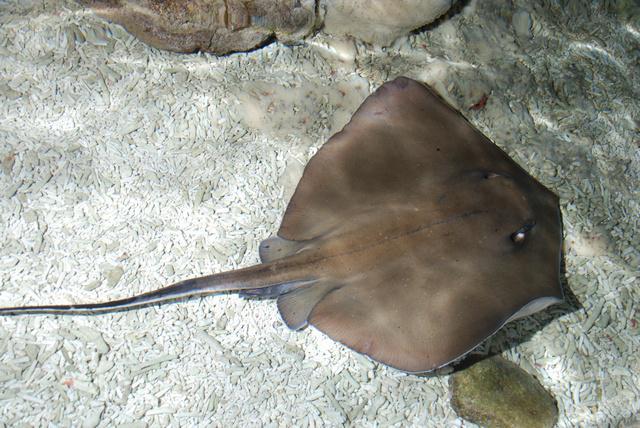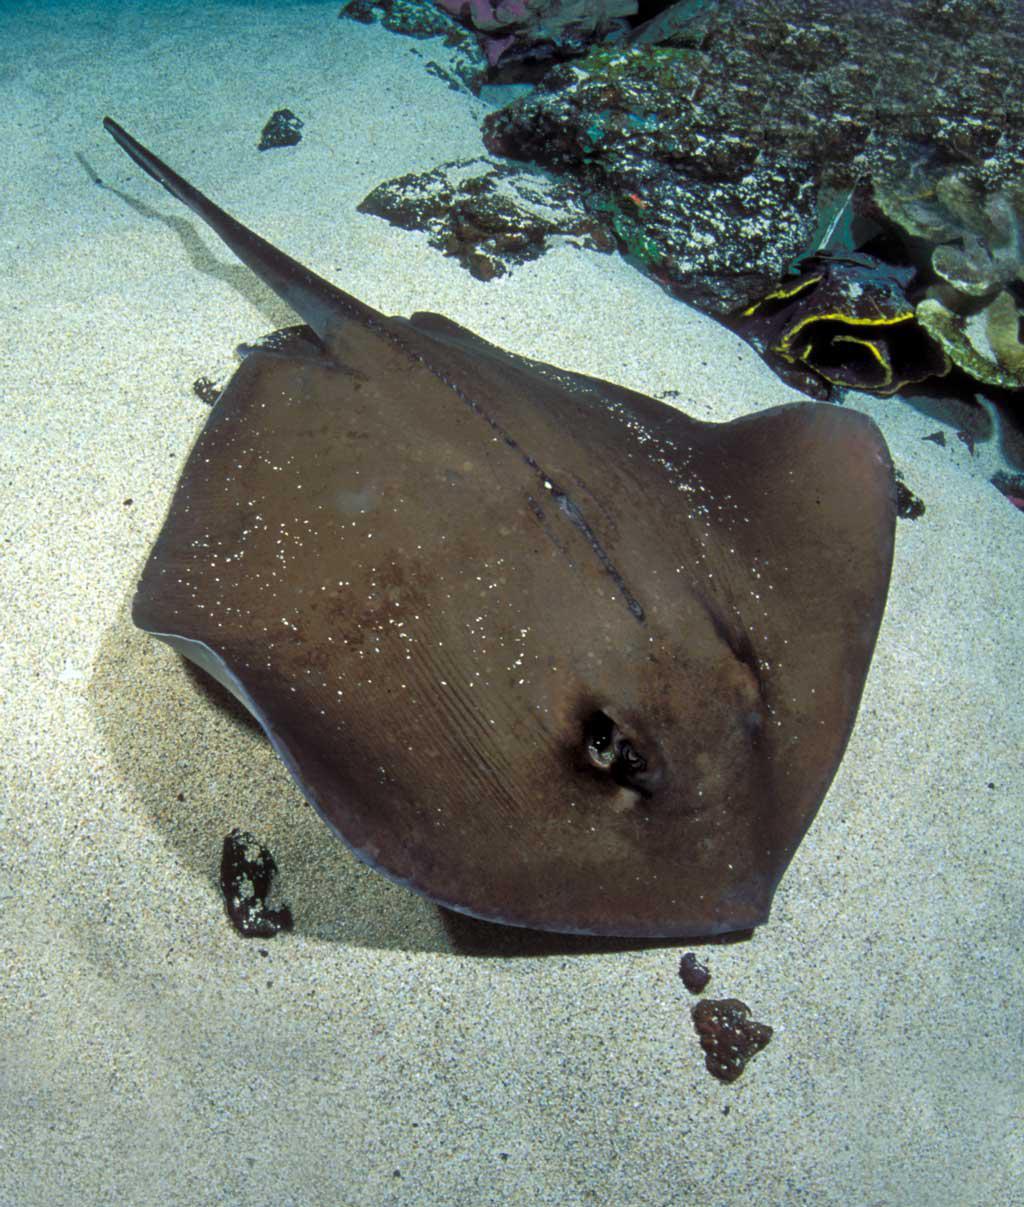The first image is the image on the left, the second image is the image on the right. Evaluate the accuracy of this statement regarding the images: "The tail of the animal in the image on the left touches the left side of the image.". Is it true? Answer yes or no. Yes. 